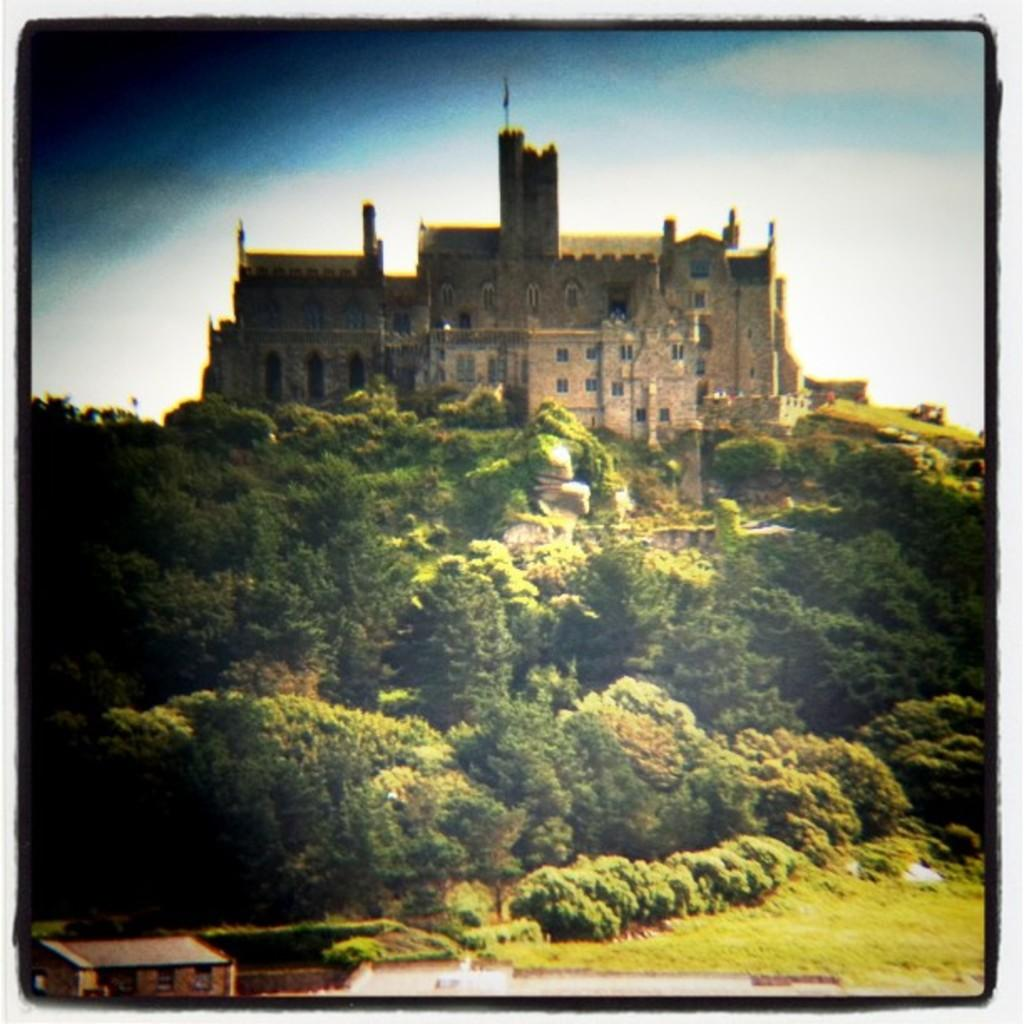What type of vegetation can be seen in the image? There are trees and grass in the image. What type of structure is present in the image? There is a castle and a building in the image. What can be seen in the sky in the image? There are clouds visible in the sky, and the sky is also visible in the image. What type of van can be seen parked near the castle in the image? There is no van present in the image; it only features trees, grass, a castle, a building, clouds, and the sky. 